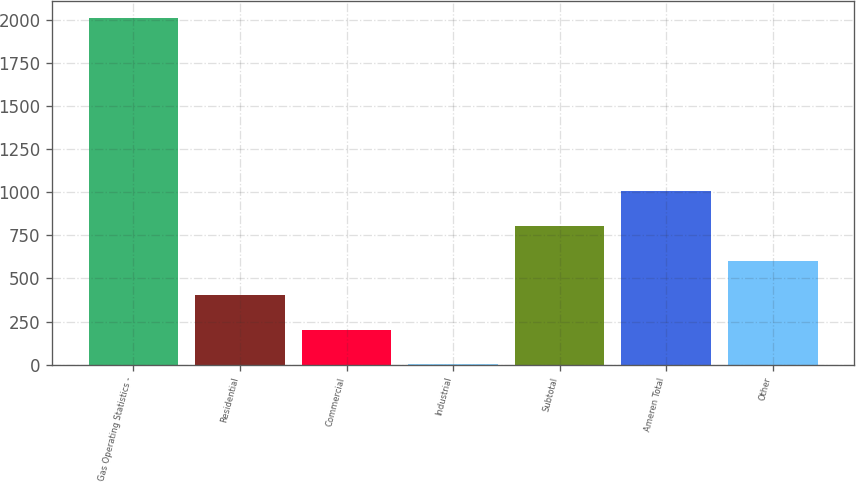Convert chart to OTSL. <chart><loc_0><loc_0><loc_500><loc_500><bar_chart><fcel>Gas Operating Statistics -<fcel>Residential<fcel>Commercial<fcel>Industrial<fcel>Subtotal<fcel>Ameren Total<fcel>Other<nl><fcel>2007<fcel>402.2<fcel>201.6<fcel>1<fcel>803.4<fcel>1004<fcel>602.8<nl></chart> 